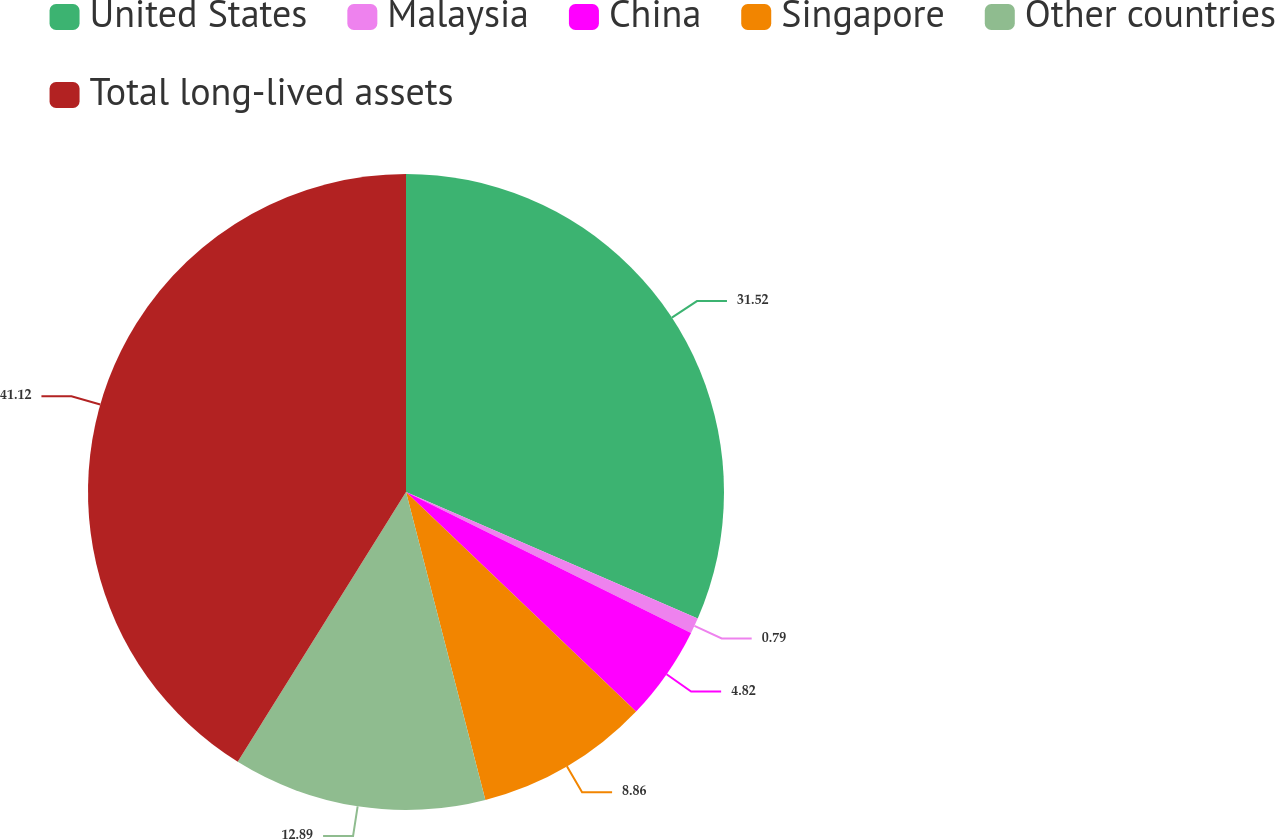<chart> <loc_0><loc_0><loc_500><loc_500><pie_chart><fcel>United States<fcel>Malaysia<fcel>China<fcel>Singapore<fcel>Other countries<fcel>Total long-lived assets<nl><fcel>31.52%<fcel>0.79%<fcel>4.82%<fcel>8.86%<fcel>12.89%<fcel>41.13%<nl></chart> 